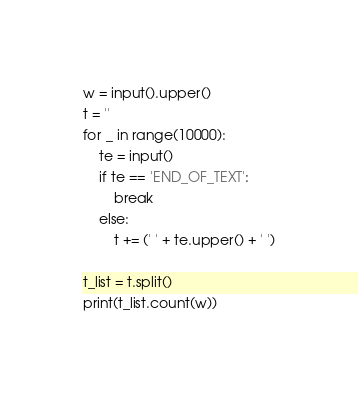<code> <loc_0><loc_0><loc_500><loc_500><_Python_>w = input().upper()
t = ''
for _ in range(10000):
    te = input()
    if te == 'END_OF_TEXT':
        break
    else:
        t += (' ' + te.upper() + ' ')

t_list = t.split()
print(t_list.count(w))
</code> 